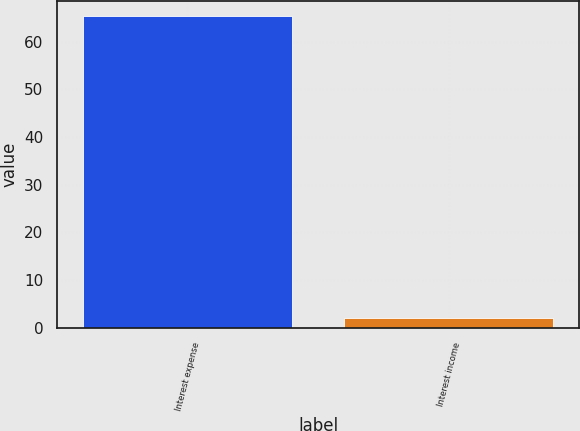<chart> <loc_0><loc_0><loc_500><loc_500><bar_chart><fcel>Interest expense<fcel>Interest income<nl><fcel>65.3<fcel>2.1<nl></chart> 